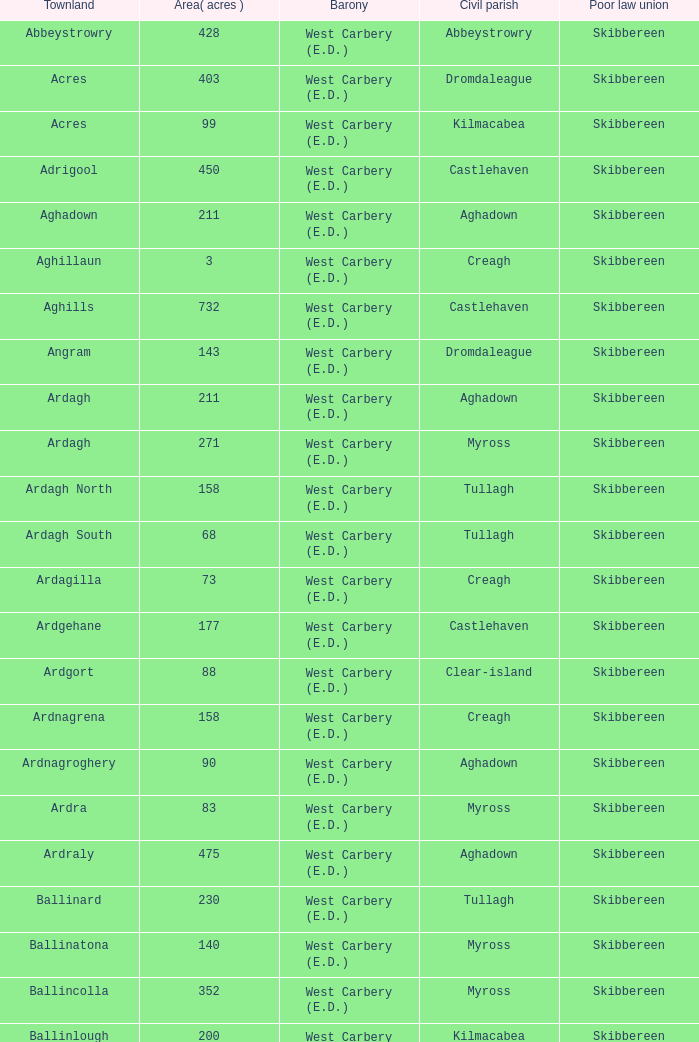When the area measures 142 acres, what do the poor law unions signify? Skibbereen. 